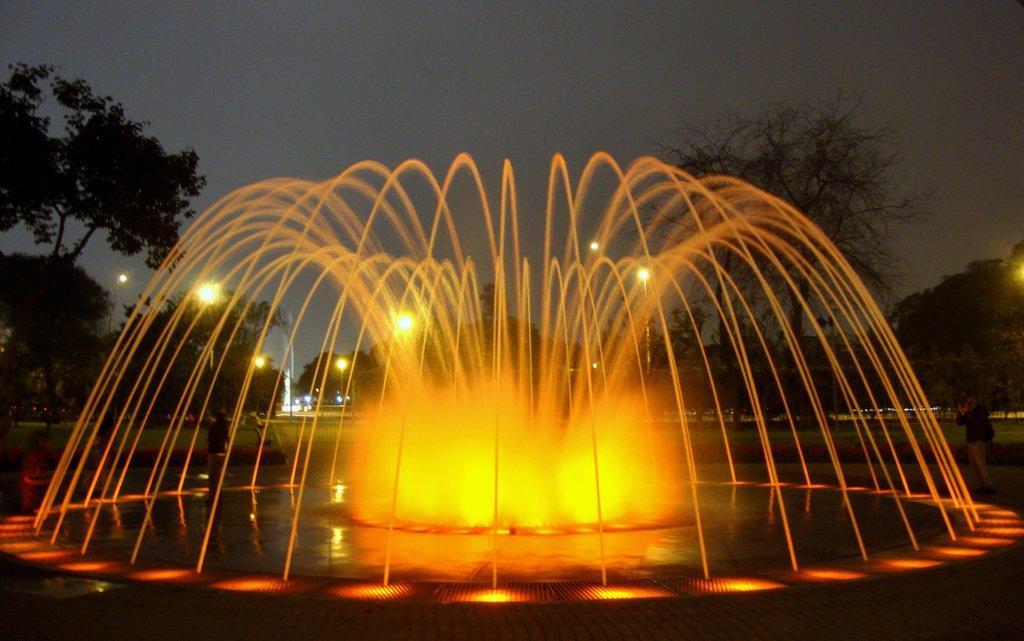Can you describe this image briefly? In this image there is the sky towards the top of the image, there is a man standing and taking a photo, there are trees, there are poles, there are street lights, there is a fountain, there is water, there is the grass. 